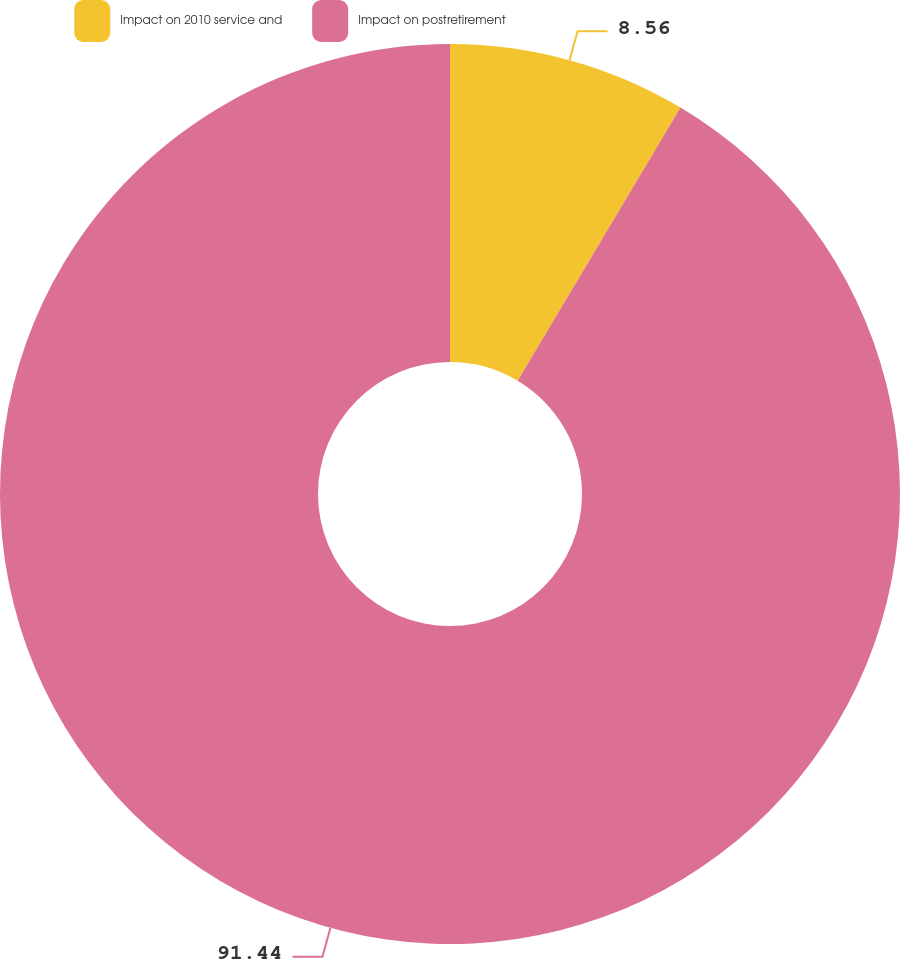<chart> <loc_0><loc_0><loc_500><loc_500><pie_chart><fcel>Impact on 2010 service and<fcel>Impact on postretirement<nl><fcel>8.56%<fcel>91.44%<nl></chart> 